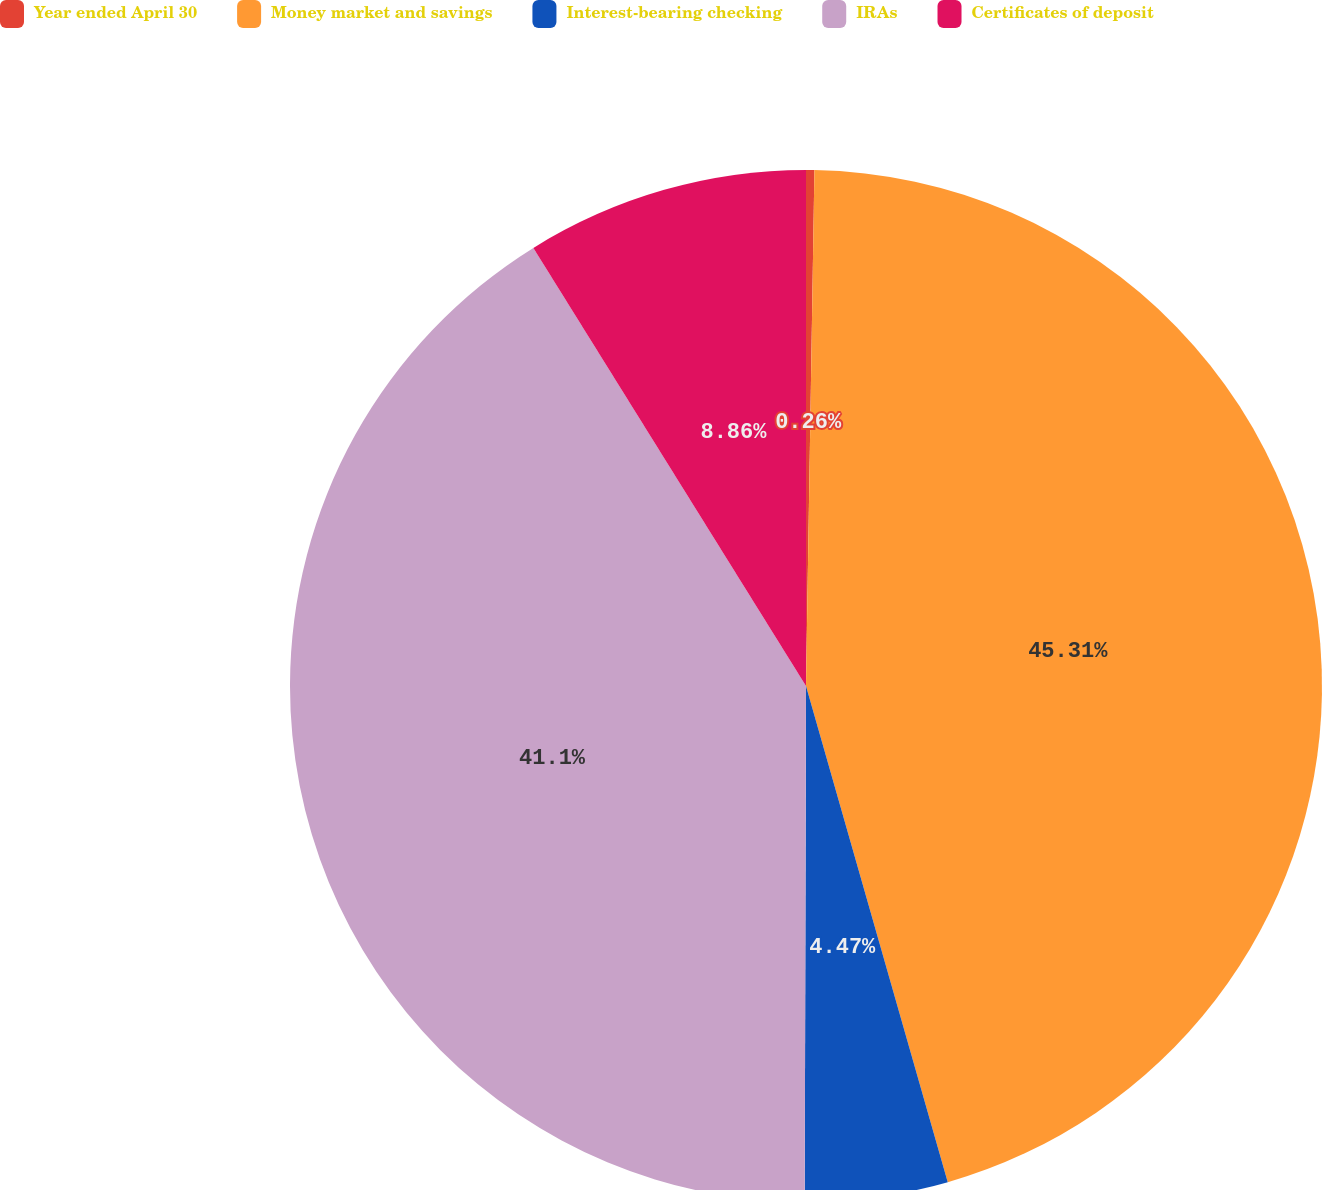<chart> <loc_0><loc_0><loc_500><loc_500><pie_chart><fcel>Year ended April 30<fcel>Money market and savings<fcel>Interest-bearing checking<fcel>IRAs<fcel>Certificates of deposit<nl><fcel>0.26%<fcel>45.31%<fcel>4.47%<fcel>41.1%<fcel>8.86%<nl></chart> 